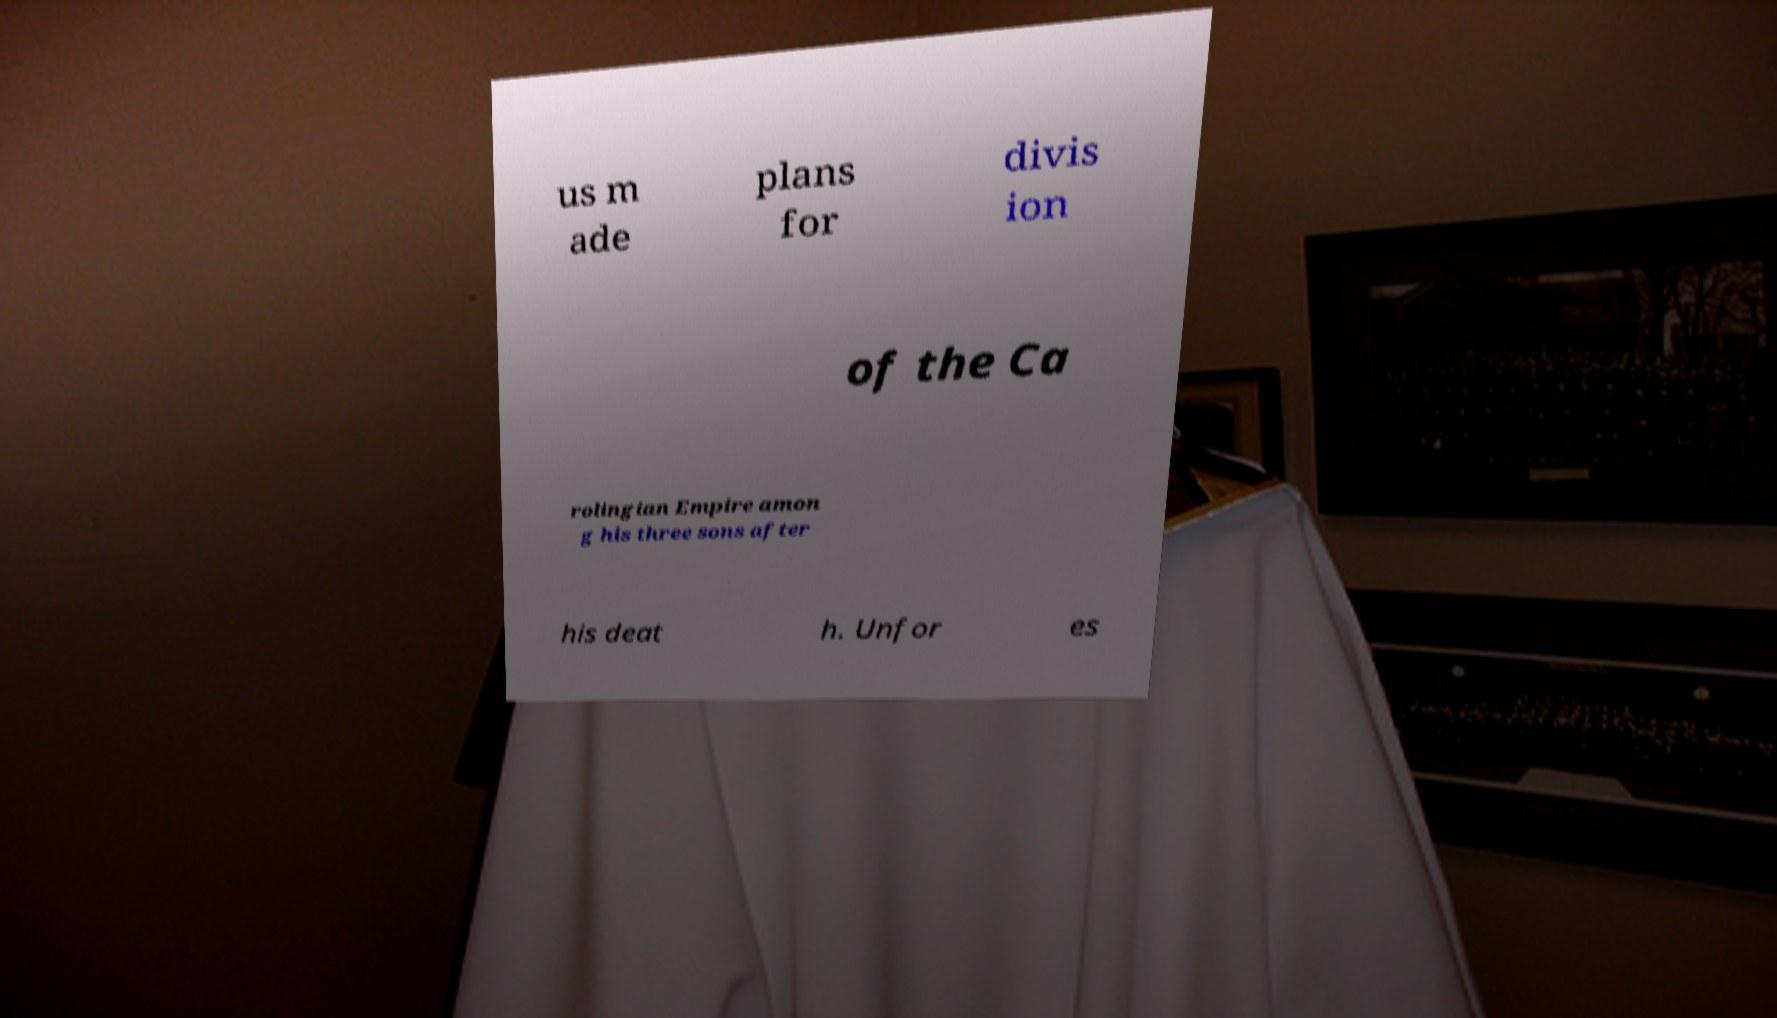There's text embedded in this image that I need extracted. Can you transcribe it verbatim? us m ade plans for divis ion of the Ca rolingian Empire amon g his three sons after his deat h. Unfor es 